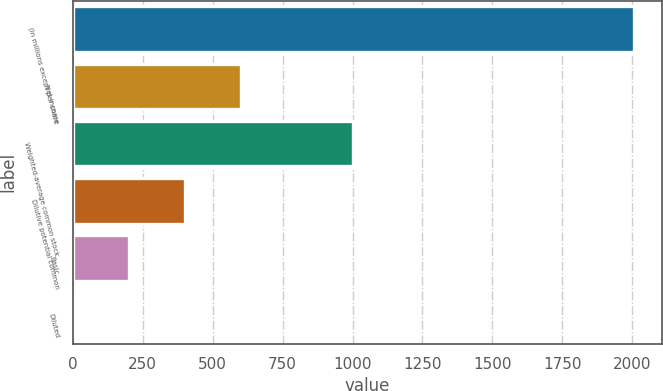Convert chart. <chart><loc_0><loc_0><loc_500><loc_500><bar_chart><fcel>(In millions except per share<fcel>Net income<fcel>Weighted-average common stock<fcel>Dilutive potential common<fcel>Basic<fcel>Diluted<nl><fcel>2006<fcel>602.34<fcel>1003.39<fcel>401.81<fcel>201.28<fcel>0.75<nl></chart> 